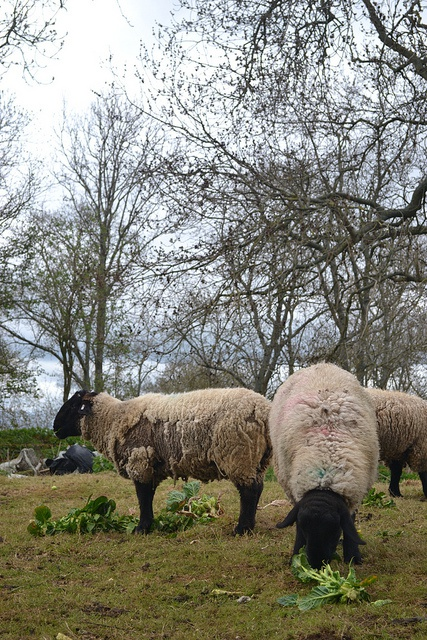Describe the objects in this image and their specific colors. I can see sheep in white, black, and gray tones, sheep in white, black, darkgray, and gray tones, and sheep in white, black, gray, and darkgray tones in this image. 